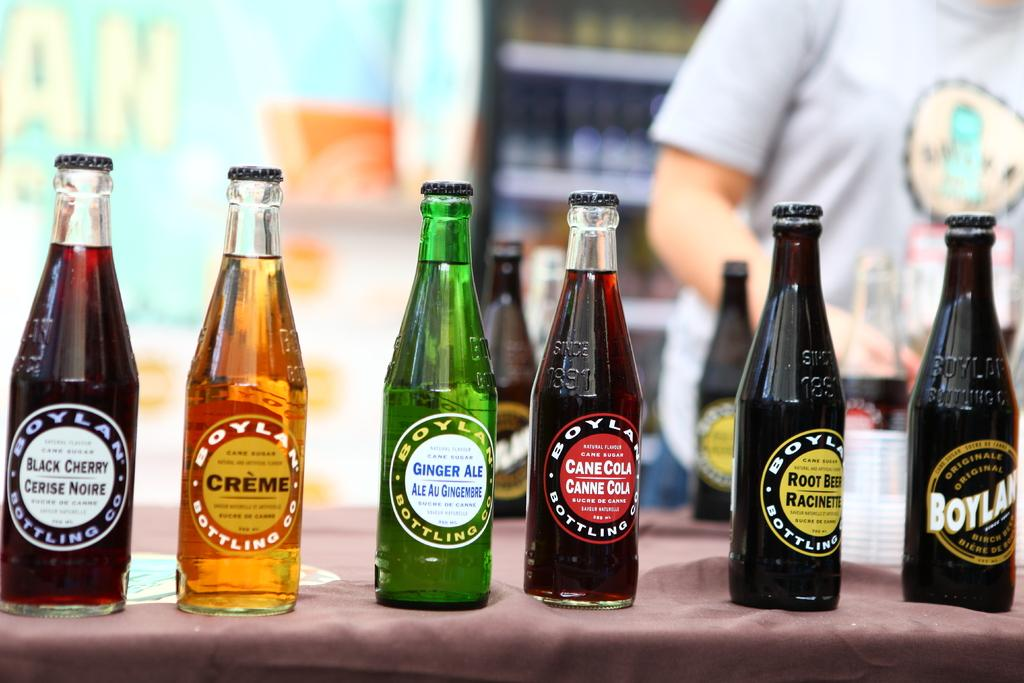<image>
Create a compact narrative representing the image presented. Six soda bottles are lined up and the green bottle is ginger ale. 